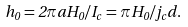Convert formula to latex. <formula><loc_0><loc_0><loc_500><loc_500>h _ { 0 } = 2 \pi a H _ { 0 } / I _ { c } = \pi H _ { 0 } / j _ { c } d .</formula> 